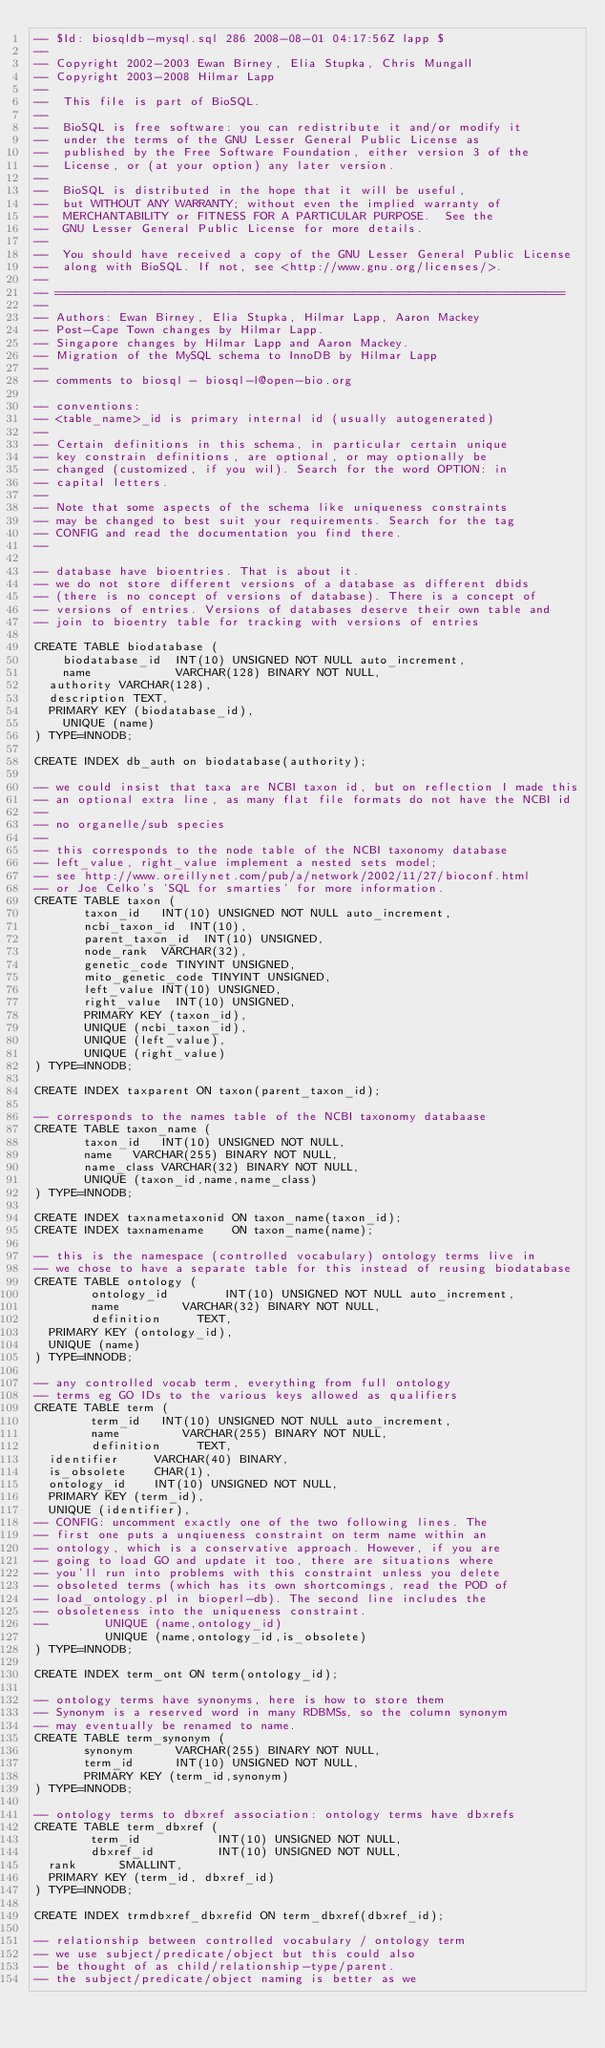<code> <loc_0><loc_0><loc_500><loc_500><_SQL_>-- $Id: biosqldb-mysql.sql 286 2008-08-01 04:17:56Z lapp $
--
-- Copyright 2002-2003 Ewan Birney, Elia Stupka, Chris Mungall
-- Copyright 2003-2008 Hilmar Lapp 
-- 
--  This file is part of BioSQL.
--
--  BioSQL is free software: you can redistribute it and/or modify it
--  under the terms of the GNU Lesser General Public License as
--  published by the Free Software Foundation, either version 3 of the
--  License, or (at your option) any later version.
--
--  BioSQL is distributed in the hope that it will be useful,
--  but WITHOUT ANY WARRANTY; without even the implied warranty of
--  MERCHANTABILITY or FITNESS FOR A PARTICULAR PURPOSE.  See the
--  GNU Lesser General Public License for more details.
--
--  You should have received a copy of the GNU Lesser General Public License
--  along with BioSQL. If not, see <http://www.gnu.org/licenses/>.
--
-- ========================================================================
--
-- Authors: Ewan Birney, Elia Stupka, Hilmar Lapp, Aaron Mackey
-- Post-Cape Town changes by Hilmar Lapp.
-- Singapore changes by Hilmar Lapp and Aaron Mackey.
-- Migration of the MySQL schema to InnoDB by Hilmar Lapp
--
-- comments to biosql - biosql-l@open-bio.org

-- conventions:
-- <table_name>_id is primary internal id (usually autogenerated)
--
-- Certain definitions in this schema, in particular certain unique
-- key constrain definitions, are optional, or may optionally be
-- changed (customized, if you wil). Search for the word OPTION: in
-- capital letters.
--
-- Note that some aspects of the schema like uniqueness constraints
-- may be changed to best suit your requirements. Search for the tag
-- CONFIG and read the documentation you find there.
--

-- database have bioentries. That is about it.
-- we do not store different versions of a database as different dbids
-- (there is no concept of versions of database). There is a concept of
-- versions of entries. Versions of databases deserve their own table and
-- join to bioentry table for tracking with versions of entries 

CREATE TABLE biodatabase (
  	biodatabase_id 	INT(10) UNSIGNED NOT NULL auto_increment,
  	name           	VARCHAR(128) BINARY NOT NULL,
	authority	VARCHAR(128),
	description	TEXT,
	PRIMARY KEY (biodatabase_id),
  	UNIQUE (name)
) TYPE=INNODB;

CREATE INDEX db_auth on biodatabase(authority);

-- we could insist that taxa are NCBI taxon id, but on reflection I made this
-- an optional extra line, as many flat file formats do not have the NCBI id
--
-- no organelle/sub species
--
-- this corresponds to the node table of the NCBI taxonomy database 
-- left_value, right_value implement a nested sets model;
-- see http://www.oreillynet.com/pub/a/network/2002/11/27/bioconf.html
-- or Joe Celko's 'SQL for smarties' for more information.
CREATE TABLE taxon (
       taxon_id		INT(10) UNSIGNED NOT NULL auto_increment,
       ncbi_taxon_id 	INT(10),
       parent_taxon_id	INT(10) UNSIGNED,
       node_rank	VARCHAR(32),
       genetic_code	TINYINT UNSIGNED,
       mito_genetic_code TINYINT UNSIGNED,
       left_value	INT(10) UNSIGNED,
       right_value	INT(10) UNSIGNED,
       PRIMARY KEY (taxon_id),
       UNIQUE (ncbi_taxon_id),
       UNIQUE (left_value),
       UNIQUE (right_value)
) TYPE=INNODB;

CREATE INDEX taxparent ON taxon(parent_taxon_id);

-- corresponds to the names table of the NCBI taxonomy databaase
CREATE TABLE taxon_name (
       taxon_id		INT(10) UNSIGNED NOT NULL,
       name		VARCHAR(255) BINARY NOT NULL,
       name_class	VARCHAR(32) BINARY NOT NULL,
       UNIQUE (taxon_id,name,name_class)
) TYPE=INNODB;

CREATE INDEX taxnametaxonid ON taxon_name(taxon_id);
CREATE INDEX taxnamename    ON taxon_name(name);

-- this is the namespace (controlled vocabulary) ontology terms live in
-- we chose to have a separate table for this instead of reusing biodatabase
CREATE TABLE ontology (
       	ontology_id        INT(10) UNSIGNED NOT NULL auto_increment,
       	name	   	   VARCHAR(32) BINARY NOT NULL,
       	definition	   TEXT,
	PRIMARY KEY (ontology_id),
	UNIQUE (name)
) TYPE=INNODB;

-- any controlled vocab term, everything from full ontology
-- terms eg GO IDs to the various keys allowed as qualifiers
CREATE TABLE term (
       	term_id   INT(10) UNSIGNED NOT NULL auto_increment,
       	name	   	   VARCHAR(255) BINARY NOT NULL,
       	definition	   TEXT,
	identifier	   VARCHAR(40) BINARY,
	is_obsolete	   CHAR(1),
	ontology_id	   INT(10) UNSIGNED NOT NULL,
	PRIMARY KEY (term_id),
	UNIQUE (identifier),
-- CONFIG: uncomment exactly one of the two following lines. The
-- first one puts a unqiueness constraint on term name within an
-- ontology, which is a conservative approach. However, if you are
-- going to load GO and update it too, there are situations where
-- you'll run into problems with this constraint unless you delete
-- obsoleted terms (which has its own shortcomings, read the POD of
-- load_ontology.pl in bioperl-db). The second line includes the
-- obsoleteness into the uniqueness constraint.
--        UNIQUE (name,ontology_id)
          UNIQUE (name,ontology_id,is_obsolete)
) TYPE=INNODB;

CREATE INDEX term_ont ON term(ontology_id);

-- ontology terms have synonyms, here is how to store them
-- Synonym is a reserved word in many RDBMSs, so the column synonym
-- may eventually be renamed to name.
CREATE TABLE term_synonym (
       synonym		  VARCHAR(255) BINARY NOT NULL,
       term_id		  INT(10) UNSIGNED NOT NULL,
       PRIMARY KEY (term_id,synonym)
) TYPE=INNODB;

-- ontology terms to dbxref association: ontology terms have dbxrefs
CREATE TABLE term_dbxref (
       	term_id	          INT(10) UNSIGNED NOT NULL,
       	dbxref_id         INT(10) UNSIGNED NOT NULL,
	rank		  SMALLINT,
	PRIMARY KEY (term_id, dbxref_id)
) TYPE=INNODB;

CREATE INDEX trmdbxref_dbxrefid ON term_dbxref(dbxref_id);

-- relationship between controlled vocabulary / ontology term
-- we use subject/predicate/object but this could also
-- be thought of as child/relationship-type/parent.
-- the subject/predicate/object naming is better as we</code> 